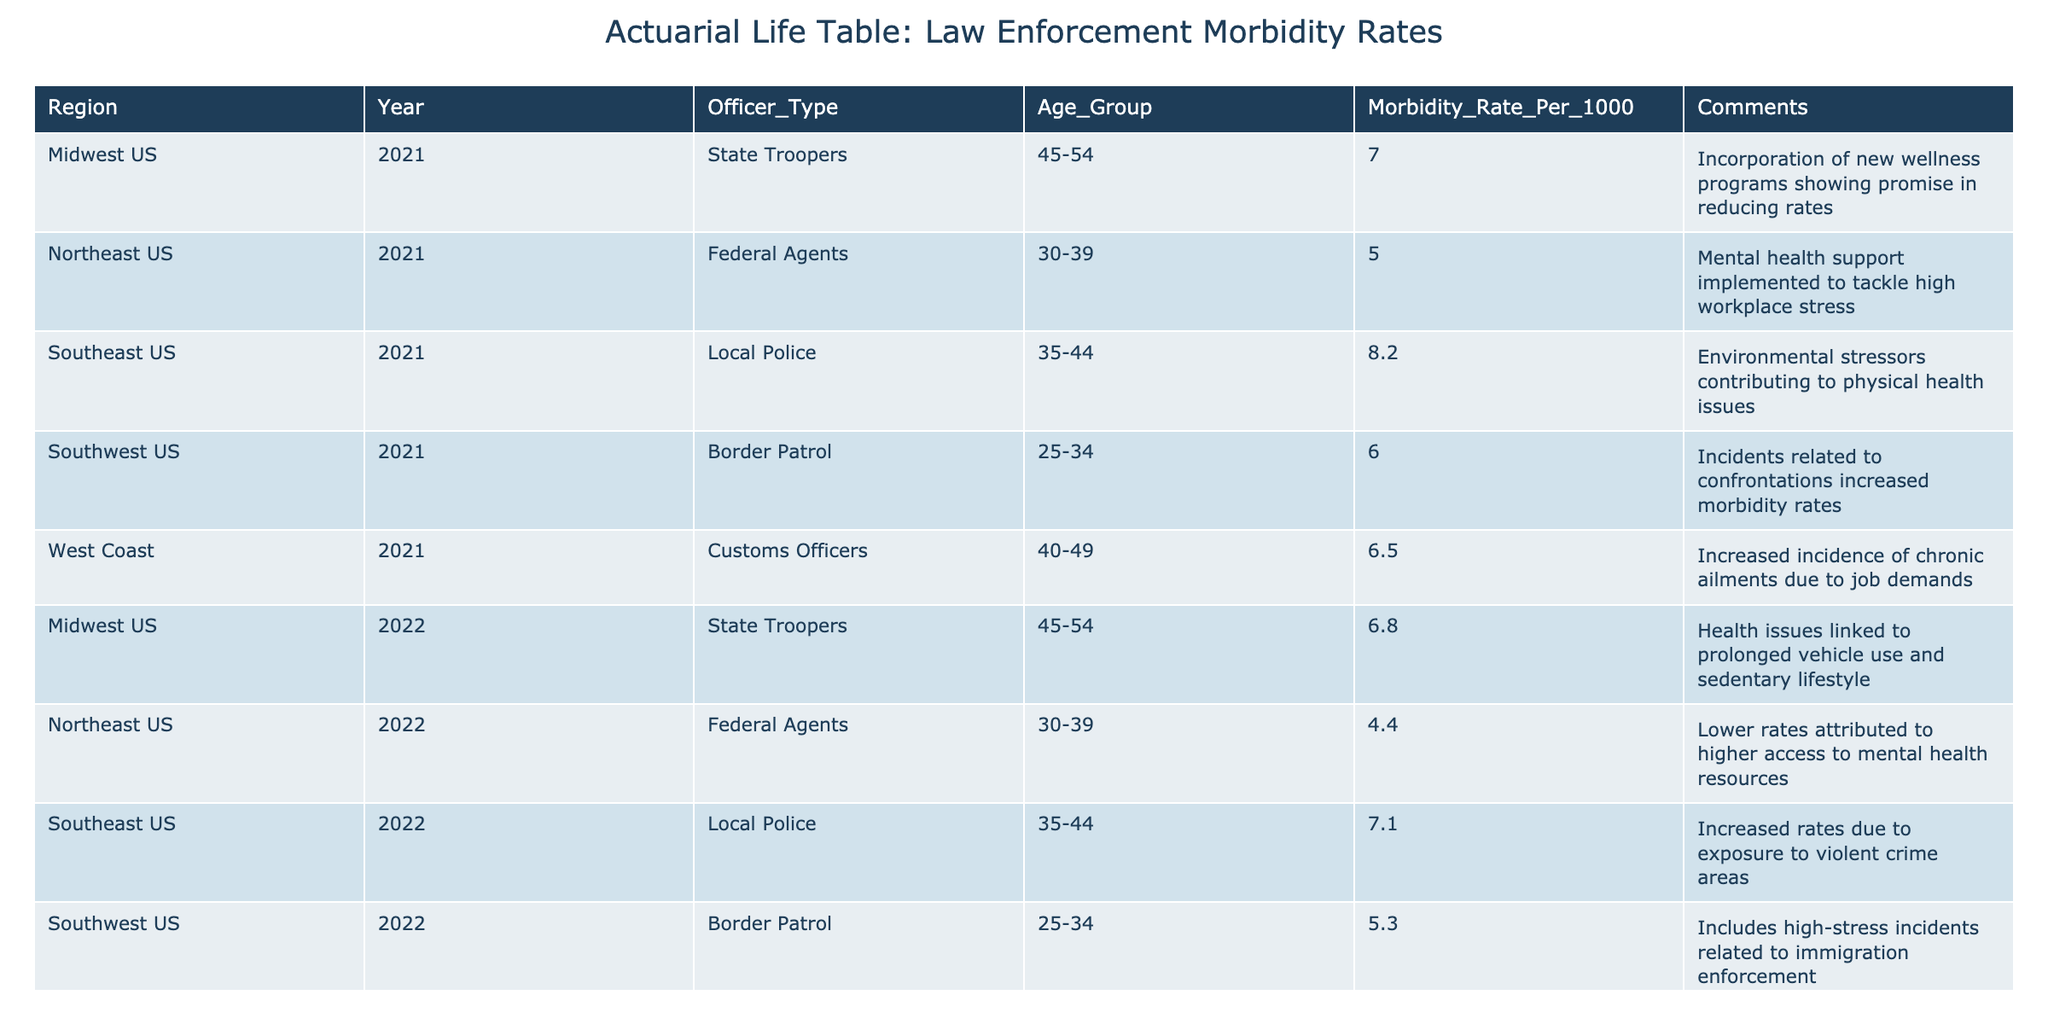What is the morbidity rate for Border Patrol officers aged 25-34 in the Southwest US for the year 2022? The table shows a specific entry for Border Patrol officers in the Southwest US for the year 2022. The morbidity rate listed for that age group is 5.3.
Answer: 5.3 Which officer type in the Southeast US had the highest morbidity rate in 2021? By looking at the values for officer types in the Southeast US for 2021, Local Police officers had the highest morbidity rate at 8.2 compared to other officer types that year.
Answer: 8.2 What is the average morbidity rate for State Troopers across both years in the Midwest US? The morbidity rates for State Troopers in the Midwest US are 6.8 in 2022 and 7.0 in 2021. To find the average, add these together: 6.8 + 7.0 = 13.8, and then divide by 2, which gives 13.8/2 = 6.9.
Answer: 6.9 Did Federal Agents have a higher morbidity rate in 2021 compared to 2022? The morbidity rate for Federal Agents in 2021 was 5.0, while in 2022, it was 4.4. Since 5.0 is greater than 4.4, the statement is true.
Answer: Yes What was the change in the morbidity rate for Customs Officers from 2021 to 2022 on the West Coast? For Customs Officers in 2021, the morbidity rate was 6.5, and in 2022 it was 5.9. The change can be calculated by finding the difference: 6.5 - 5.9 = 0.6, so the morbidity rate decreased by 0.6.
Answer: Decrease of 0.6 Which region had the lowest morbidity rate for officers aged 30-39 in 2022? In 2022, the table shows that Federal Agents in the Northeast US had a morbidity rate of 4.4, which is the lowest rate among officer types for those aged 30-39 that year.
Answer: Northeast US Is the morbidity rate for Local Police in the Southeast US higher in 2021 than in 2022? In 2021, the morbidity rate for Local Police was 8.2, and in 2022 it was 7.1. Since 8.2 is greater than 7.1, the statement is true.
Answer: Yes What was the highest morbidity rate recorded in the table across all years and officer types? Reviewing all entries, the highest morbidity rate was 8.2 for Local Police in the Southeast US in 2021, which is greater than any other recorded rates.
Answer: 8.2 